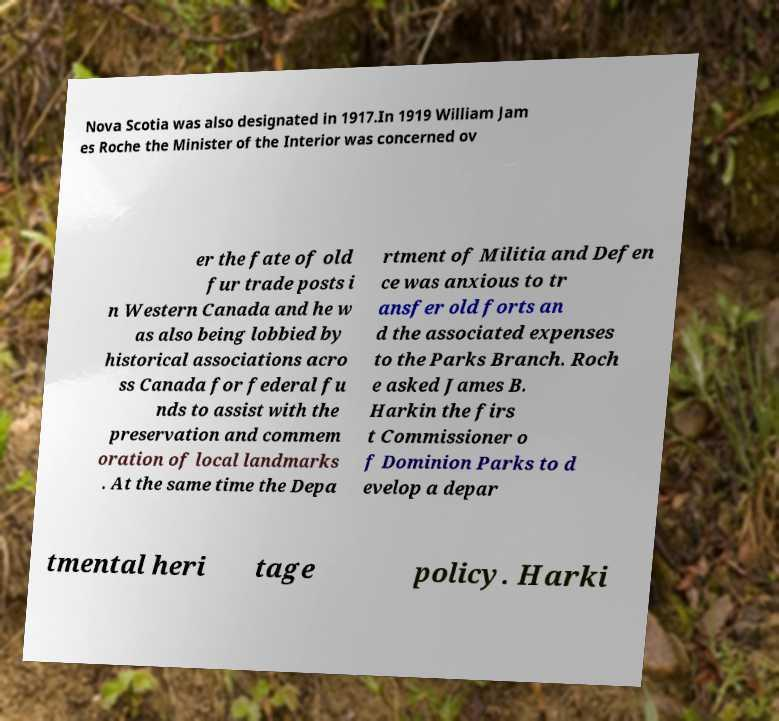Could you assist in decoding the text presented in this image and type it out clearly? Nova Scotia was also designated in 1917.In 1919 William Jam es Roche the Minister of the Interior was concerned ov er the fate of old fur trade posts i n Western Canada and he w as also being lobbied by historical associations acro ss Canada for federal fu nds to assist with the preservation and commem oration of local landmarks . At the same time the Depa rtment of Militia and Defen ce was anxious to tr ansfer old forts an d the associated expenses to the Parks Branch. Roch e asked James B. Harkin the firs t Commissioner o f Dominion Parks to d evelop a depar tmental heri tage policy. Harki 